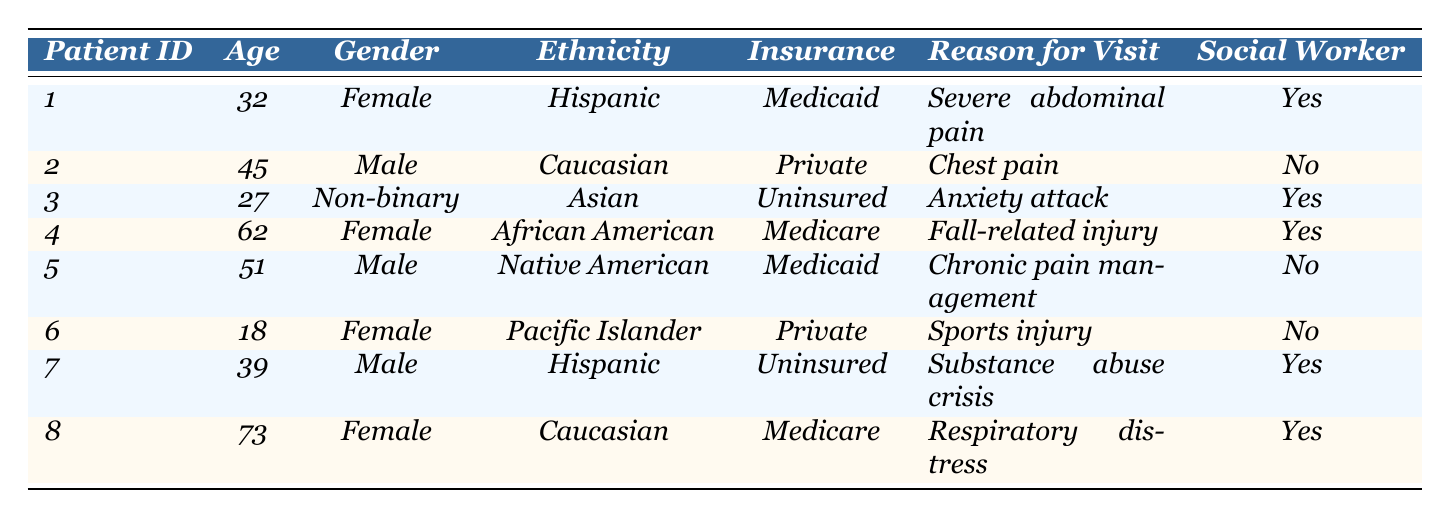What is the age of patient ID 4? The table shows that the age for patient ID 4 is listed directly in the Age column. Looking at that row, the age is 62.
Answer: 62 How many patients have Medicaid insurance? To find the number of patients with Medicaid insurance, count the occurrences of "Medicaid" in the Insurance column. There are 2 patients with Medicaid insurance (IDs 1 and 5).
Answer: 2 Is there a patient who is uninsured and has social worker involvement? By reviewing the table, patient ID 3 and patient ID 7 are uninsured. Looking at their social worker involvement, patient ID 7 has social worker involvement indicated as "Yes."
Answer: Yes What is the reason for visit for the youngest patient? The youngest patient is patient ID 6, who is 18 years old. Checking the Reason for Visit column for this patient, the reason for visit is "Sports injury."
Answer: Sports injury What is the average age of patients involved with a social worker? Patients involved with a social worker are IDs 1, 3, 4, 7, and 8. Their ages are 32, 27, 62, 39, and 73. The average age is calculated as (32 + 27 + 62 + 39 + 73) = 233, and dividing by 5 gives an average of 46.6, which we can round to 47.
Answer: 47 How many patients visited for abdominal pain or respiratory distress? Check the Reason for Visit column for keywords. Patient ID 1 visited for "Severe abdominal pain," and patient ID 8 for "Respiratory distress." Therefore, adding these two gives us a total of 2 patients.
Answer: 2 Are there more male or female patients in the table? Count the occurrences of males and females in the Gender column. There are 3 females (IDs 1, 4, 6, and 8) and 3 males (IDs 2, 5, and 7). This indicates there is an equal number of male and female patients.
Answer: Equal Which ethnicity has the highest representation among the listed patients? Review the Ethnicity column and count the occurrences for each ethnicity: Hispanic (2), Caucasian (2), African American (1), Native American (1), Asian (1), Pacific Islander (1). The highest representation is by Hispanic and Caucasian both with 2.
Answer: Hispanic and Caucasian What are the reasons for visits of uninsured patients? Uninsured patients are IDs 3 and 7. Checking their reasons for visit, patient ID 3's reason is "Anxiety attack" and patient ID 7's reason is "Substance abuse crisis." Hence, the reasons are "Anxiety attack" and "Substance abuse crisis."
Answer: Anxiety attack and Substance abuse crisis Which insurance status is the only one associated with both male and female patients in the table? Review the Insurance column and count the occurrences based on gender. Medicaid is present for both a female (ID 1) and a male (ID 5), while other insurance statuses are only associated with one gender. Thus, the answer is Medicaid.
Answer: Medicaid 